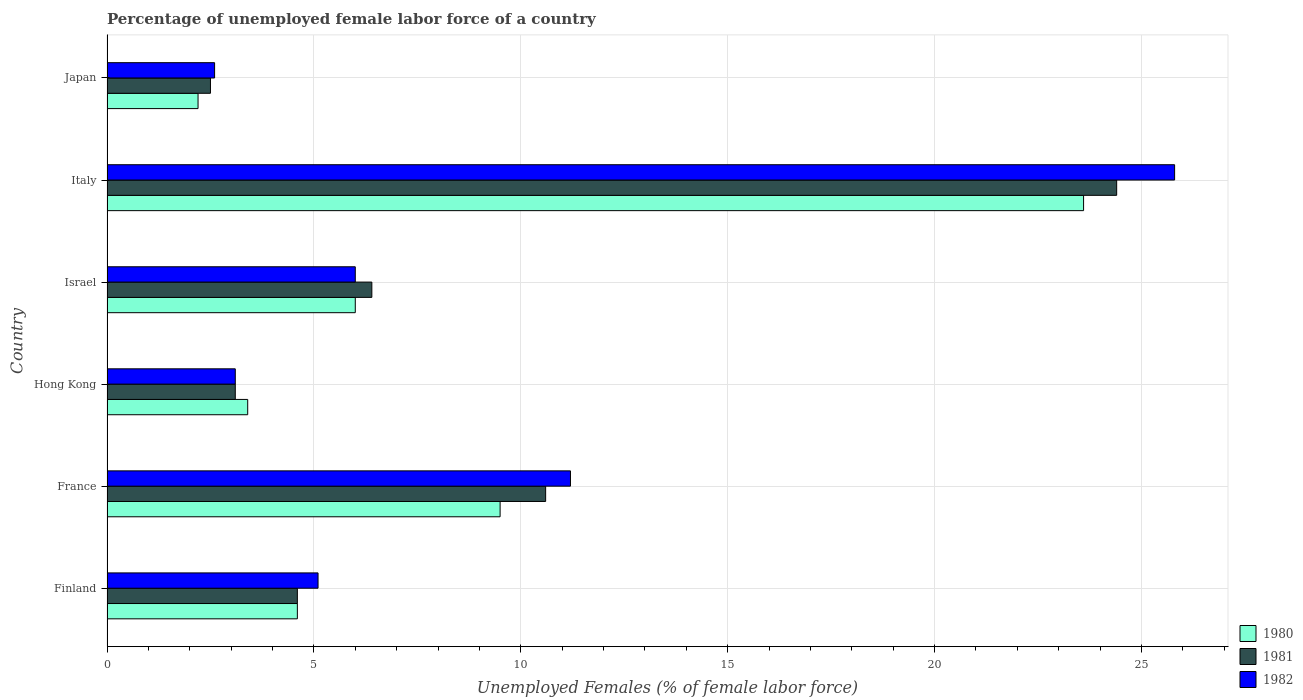Are the number of bars per tick equal to the number of legend labels?
Give a very brief answer. Yes. Are the number of bars on each tick of the Y-axis equal?
Your response must be concise. Yes. What is the label of the 3rd group of bars from the top?
Provide a short and direct response. Israel. What is the percentage of unemployed female labor force in 1982 in France?
Your answer should be very brief. 11.2. Across all countries, what is the maximum percentage of unemployed female labor force in 1980?
Ensure brevity in your answer.  23.6. Across all countries, what is the minimum percentage of unemployed female labor force in 1982?
Your response must be concise. 2.6. In which country was the percentage of unemployed female labor force in 1981 maximum?
Your response must be concise. Italy. What is the total percentage of unemployed female labor force in 1980 in the graph?
Offer a terse response. 49.3. What is the difference between the percentage of unemployed female labor force in 1980 in Finland and that in Japan?
Your answer should be compact. 2.4. What is the average percentage of unemployed female labor force in 1981 per country?
Your answer should be compact. 8.6. What is the difference between the percentage of unemployed female labor force in 1982 and percentage of unemployed female labor force in 1981 in Japan?
Your answer should be very brief. 0.1. What is the ratio of the percentage of unemployed female labor force in 1980 in France to that in Italy?
Offer a terse response. 0.4. What is the difference between the highest and the second highest percentage of unemployed female labor force in 1982?
Offer a terse response. 14.6. What is the difference between the highest and the lowest percentage of unemployed female labor force in 1982?
Give a very brief answer. 23.2. In how many countries, is the percentage of unemployed female labor force in 1981 greater than the average percentage of unemployed female labor force in 1981 taken over all countries?
Give a very brief answer. 2. Is the sum of the percentage of unemployed female labor force in 1981 in Israel and Japan greater than the maximum percentage of unemployed female labor force in 1980 across all countries?
Make the answer very short. No. What does the 1st bar from the top in France represents?
Provide a succinct answer. 1982. Is it the case that in every country, the sum of the percentage of unemployed female labor force in 1980 and percentage of unemployed female labor force in 1981 is greater than the percentage of unemployed female labor force in 1982?
Provide a short and direct response. Yes. How many bars are there?
Provide a short and direct response. 18. What is the difference between two consecutive major ticks on the X-axis?
Offer a terse response. 5. Does the graph contain grids?
Keep it short and to the point. Yes. What is the title of the graph?
Give a very brief answer. Percentage of unemployed female labor force of a country. What is the label or title of the X-axis?
Offer a very short reply. Unemployed Females (% of female labor force). What is the label or title of the Y-axis?
Give a very brief answer. Country. What is the Unemployed Females (% of female labor force) in 1980 in Finland?
Provide a succinct answer. 4.6. What is the Unemployed Females (% of female labor force) in 1981 in Finland?
Your response must be concise. 4.6. What is the Unemployed Females (% of female labor force) in 1982 in Finland?
Give a very brief answer. 5.1. What is the Unemployed Females (% of female labor force) of 1980 in France?
Provide a short and direct response. 9.5. What is the Unemployed Females (% of female labor force) of 1981 in France?
Keep it short and to the point. 10.6. What is the Unemployed Females (% of female labor force) of 1982 in France?
Make the answer very short. 11.2. What is the Unemployed Females (% of female labor force) in 1980 in Hong Kong?
Your answer should be compact. 3.4. What is the Unemployed Females (% of female labor force) in 1981 in Hong Kong?
Give a very brief answer. 3.1. What is the Unemployed Females (% of female labor force) in 1982 in Hong Kong?
Ensure brevity in your answer.  3.1. What is the Unemployed Females (% of female labor force) in 1980 in Israel?
Provide a short and direct response. 6. What is the Unemployed Females (% of female labor force) of 1981 in Israel?
Ensure brevity in your answer.  6.4. What is the Unemployed Females (% of female labor force) of 1980 in Italy?
Keep it short and to the point. 23.6. What is the Unemployed Females (% of female labor force) of 1981 in Italy?
Offer a very short reply. 24.4. What is the Unemployed Females (% of female labor force) in 1982 in Italy?
Offer a terse response. 25.8. What is the Unemployed Females (% of female labor force) in 1980 in Japan?
Offer a terse response. 2.2. What is the Unemployed Females (% of female labor force) of 1981 in Japan?
Give a very brief answer. 2.5. What is the Unemployed Females (% of female labor force) of 1982 in Japan?
Ensure brevity in your answer.  2.6. Across all countries, what is the maximum Unemployed Females (% of female labor force) of 1980?
Your answer should be compact. 23.6. Across all countries, what is the maximum Unemployed Females (% of female labor force) in 1981?
Make the answer very short. 24.4. Across all countries, what is the maximum Unemployed Females (% of female labor force) of 1982?
Provide a short and direct response. 25.8. Across all countries, what is the minimum Unemployed Females (% of female labor force) in 1980?
Ensure brevity in your answer.  2.2. Across all countries, what is the minimum Unemployed Females (% of female labor force) in 1982?
Your answer should be compact. 2.6. What is the total Unemployed Females (% of female labor force) of 1980 in the graph?
Provide a short and direct response. 49.3. What is the total Unemployed Females (% of female labor force) in 1981 in the graph?
Your answer should be compact. 51.6. What is the total Unemployed Females (% of female labor force) in 1982 in the graph?
Your answer should be compact. 53.8. What is the difference between the Unemployed Females (% of female labor force) in 1982 in Finland and that in France?
Offer a terse response. -6.1. What is the difference between the Unemployed Females (% of female labor force) of 1980 in Finland and that in Hong Kong?
Ensure brevity in your answer.  1.2. What is the difference between the Unemployed Females (% of female labor force) of 1980 in Finland and that in Israel?
Your answer should be compact. -1.4. What is the difference between the Unemployed Females (% of female labor force) in 1981 in Finland and that in Israel?
Your answer should be very brief. -1.8. What is the difference between the Unemployed Females (% of female labor force) in 1980 in Finland and that in Italy?
Your answer should be compact. -19. What is the difference between the Unemployed Females (% of female labor force) of 1981 in Finland and that in Italy?
Your answer should be very brief. -19.8. What is the difference between the Unemployed Females (% of female labor force) of 1982 in Finland and that in Italy?
Ensure brevity in your answer.  -20.7. What is the difference between the Unemployed Females (% of female labor force) of 1980 in Finland and that in Japan?
Provide a short and direct response. 2.4. What is the difference between the Unemployed Females (% of female labor force) of 1981 in Finland and that in Japan?
Provide a short and direct response. 2.1. What is the difference between the Unemployed Females (% of female labor force) in 1982 in Finland and that in Japan?
Give a very brief answer. 2.5. What is the difference between the Unemployed Females (% of female labor force) in 1980 in France and that in Hong Kong?
Offer a terse response. 6.1. What is the difference between the Unemployed Females (% of female labor force) of 1981 in France and that in Hong Kong?
Offer a terse response. 7.5. What is the difference between the Unemployed Females (% of female labor force) in 1980 in France and that in Israel?
Your response must be concise. 3.5. What is the difference between the Unemployed Females (% of female labor force) of 1980 in France and that in Italy?
Give a very brief answer. -14.1. What is the difference between the Unemployed Females (% of female labor force) in 1982 in France and that in Italy?
Your answer should be very brief. -14.6. What is the difference between the Unemployed Females (% of female labor force) in 1982 in France and that in Japan?
Your response must be concise. 8.6. What is the difference between the Unemployed Females (% of female labor force) in 1980 in Hong Kong and that in Israel?
Provide a succinct answer. -2.6. What is the difference between the Unemployed Females (% of female labor force) of 1981 in Hong Kong and that in Israel?
Offer a very short reply. -3.3. What is the difference between the Unemployed Females (% of female labor force) of 1980 in Hong Kong and that in Italy?
Provide a succinct answer. -20.2. What is the difference between the Unemployed Females (% of female labor force) in 1981 in Hong Kong and that in Italy?
Offer a very short reply. -21.3. What is the difference between the Unemployed Females (% of female labor force) in 1982 in Hong Kong and that in Italy?
Your answer should be compact. -22.7. What is the difference between the Unemployed Females (% of female labor force) in 1980 in Hong Kong and that in Japan?
Your answer should be compact. 1.2. What is the difference between the Unemployed Females (% of female labor force) of 1981 in Hong Kong and that in Japan?
Your answer should be compact. 0.6. What is the difference between the Unemployed Females (% of female labor force) of 1982 in Hong Kong and that in Japan?
Your answer should be very brief. 0.5. What is the difference between the Unemployed Females (% of female labor force) in 1980 in Israel and that in Italy?
Provide a short and direct response. -17.6. What is the difference between the Unemployed Females (% of female labor force) of 1981 in Israel and that in Italy?
Your response must be concise. -18. What is the difference between the Unemployed Females (% of female labor force) in 1982 in Israel and that in Italy?
Make the answer very short. -19.8. What is the difference between the Unemployed Females (% of female labor force) in 1980 in Israel and that in Japan?
Your answer should be very brief. 3.8. What is the difference between the Unemployed Females (% of female labor force) of 1981 in Israel and that in Japan?
Offer a very short reply. 3.9. What is the difference between the Unemployed Females (% of female labor force) in 1982 in Israel and that in Japan?
Provide a succinct answer. 3.4. What is the difference between the Unemployed Females (% of female labor force) of 1980 in Italy and that in Japan?
Give a very brief answer. 21.4. What is the difference between the Unemployed Females (% of female labor force) in 1981 in Italy and that in Japan?
Keep it short and to the point. 21.9. What is the difference between the Unemployed Females (% of female labor force) in 1982 in Italy and that in Japan?
Give a very brief answer. 23.2. What is the difference between the Unemployed Females (% of female labor force) of 1980 in Finland and the Unemployed Females (% of female labor force) of 1981 in France?
Provide a succinct answer. -6. What is the difference between the Unemployed Females (% of female labor force) in 1981 in Finland and the Unemployed Females (% of female labor force) in 1982 in Hong Kong?
Give a very brief answer. 1.5. What is the difference between the Unemployed Females (% of female labor force) in 1980 in Finland and the Unemployed Females (% of female labor force) in 1982 in Israel?
Give a very brief answer. -1.4. What is the difference between the Unemployed Females (% of female labor force) of 1980 in Finland and the Unemployed Females (% of female labor force) of 1981 in Italy?
Make the answer very short. -19.8. What is the difference between the Unemployed Females (% of female labor force) of 1980 in Finland and the Unemployed Females (% of female labor force) of 1982 in Italy?
Provide a succinct answer. -21.2. What is the difference between the Unemployed Females (% of female labor force) in 1981 in Finland and the Unemployed Females (% of female labor force) in 1982 in Italy?
Provide a short and direct response. -21.2. What is the difference between the Unemployed Females (% of female labor force) in 1980 in France and the Unemployed Females (% of female labor force) in 1982 in Hong Kong?
Keep it short and to the point. 6.4. What is the difference between the Unemployed Females (% of female labor force) in 1981 in France and the Unemployed Females (% of female labor force) in 1982 in Hong Kong?
Ensure brevity in your answer.  7.5. What is the difference between the Unemployed Females (% of female labor force) of 1980 in France and the Unemployed Females (% of female labor force) of 1981 in Israel?
Make the answer very short. 3.1. What is the difference between the Unemployed Females (% of female labor force) of 1981 in France and the Unemployed Females (% of female labor force) of 1982 in Israel?
Keep it short and to the point. 4.6. What is the difference between the Unemployed Females (% of female labor force) of 1980 in France and the Unemployed Females (% of female labor force) of 1981 in Italy?
Your response must be concise. -14.9. What is the difference between the Unemployed Females (% of female labor force) in 1980 in France and the Unemployed Females (% of female labor force) in 1982 in Italy?
Give a very brief answer. -16.3. What is the difference between the Unemployed Females (% of female labor force) of 1981 in France and the Unemployed Females (% of female labor force) of 1982 in Italy?
Your answer should be compact. -15.2. What is the difference between the Unemployed Females (% of female labor force) in 1980 in France and the Unemployed Females (% of female labor force) in 1982 in Japan?
Make the answer very short. 6.9. What is the difference between the Unemployed Females (% of female labor force) of 1980 in Hong Kong and the Unemployed Females (% of female labor force) of 1982 in Israel?
Offer a very short reply. -2.6. What is the difference between the Unemployed Females (% of female labor force) in 1980 in Hong Kong and the Unemployed Females (% of female labor force) in 1981 in Italy?
Your response must be concise. -21. What is the difference between the Unemployed Females (% of female labor force) of 1980 in Hong Kong and the Unemployed Females (% of female labor force) of 1982 in Italy?
Provide a short and direct response. -22.4. What is the difference between the Unemployed Females (% of female labor force) in 1981 in Hong Kong and the Unemployed Females (% of female labor force) in 1982 in Italy?
Provide a short and direct response. -22.7. What is the difference between the Unemployed Females (% of female labor force) of 1980 in Hong Kong and the Unemployed Females (% of female labor force) of 1981 in Japan?
Make the answer very short. 0.9. What is the difference between the Unemployed Females (% of female labor force) in 1980 in Israel and the Unemployed Females (% of female labor force) in 1981 in Italy?
Provide a short and direct response. -18.4. What is the difference between the Unemployed Females (% of female labor force) of 1980 in Israel and the Unemployed Females (% of female labor force) of 1982 in Italy?
Offer a very short reply. -19.8. What is the difference between the Unemployed Females (% of female labor force) in 1981 in Israel and the Unemployed Females (% of female labor force) in 1982 in Italy?
Provide a short and direct response. -19.4. What is the difference between the Unemployed Females (% of female labor force) in 1980 in Italy and the Unemployed Females (% of female labor force) in 1981 in Japan?
Give a very brief answer. 21.1. What is the difference between the Unemployed Females (% of female labor force) of 1981 in Italy and the Unemployed Females (% of female labor force) of 1982 in Japan?
Your answer should be very brief. 21.8. What is the average Unemployed Females (% of female labor force) in 1980 per country?
Your answer should be very brief. 8.22. What is the average Unemployed Females (% of female labor force) in 1981 per country?
Your answer should be compact. 8.6. What is the average Unemployed Females (% of female labor force) in 1982 per country?
Your answer should be very brief. 8.97. What is the difference between the Unemployed Females (% of female labor force) of 1980 and Unemployed Females (% of female labor force) of 1981 in France?
Your answer should be compact. -1.1. What is the difference between the Unemployed Females (% of female labor force) of 1980 and Unemployed Females (% of female labor force) of 1982 in France?
Your answer should be very brief. -1.7. What is the difference between the Unemployed Females (% of female labor force) in 1980 and Unemployed Females (% of female labor force) in 1981 in Hong Kong?
Provide a succinct answer. 0.3. What is the difference between the Unemployed Females (% of female labor force) of 1980 and Unemployed Females (% of female labor force) of 1982 in Israel?
Your answer should be very brief. 0. What is the difference between the Unemployed Females (% of female labor force) of 1981 and Unemployed Females (% of female labor force) of 1982 in Israel?
Give a very brief answer. 0.4. What is the difference between the Unemployed Females (% of female labor force) of 1981 and Unemployed Females (% of female labor force) of 1982 in Italy?
Your answer should be very brief. -1.4. What is the difference between the Unemployed Females (% of female labor force) in 1980 and Unemployed Females (% of female labor force) in 1982 in Japan?
Offer a terse response. -0.4. What is the ratio of the Unemployed Females (% of female labor force) in 1980 in Finland to that in France?
Offer a very short reply. 0.48. What is the ratio of the Unemployed Females (% of female labor force) in 1981 in Finland to that in France?
Your answer should be compact. 0.43. What is the ratio of the Unemployed Females (% of female labor force) in 1982 in Finland to that in France?
Your answer should be very brief. 0.46. What is the ratio of the Unemployed Females (% of female labor force) in 1980 in Finland to that in Hong Kong?
Make the answer very short. 1.35. What is the ratio of the Unemployed Females (% of female labor force) of 1981 in Finland to that in Hong Kong?
Provide a succinct answer. 1.48. What is the ratio of the Unemployed Females (% of female labor force) of 1982 in Finland to that in Hong Kong?
Give a very brief answer. 1.65. What is the ratio of the Unemployed Females (% of female labor force) in 1980 in Finland to that in Israel?
Provide a succinct answer. 0.77. What is the ratio of the Unemployed Females (% of female labor force) in 1981 in Finland to that in Israel?
Ensure brevity in your answer.  0.72. What is the ratio of the Unemployed Females (% of female labor force) of 1980 in Finland to that in Italy?
Provide a short and direct response. 0.19. What is the ratio of the Unemployed Females (% of female labor force) of 1981 in Finland to that in Italy?
Your answer should be compact. 0.19. What is the ratio of the Unemployed Females (% of female labor force) of 1982 in Finland to that in Italy?
Your response must be concise. 0.2. What is the ratio of the Unemployed Females (% of female labor force) in 1980 in Finland to that in Japan?
Ensure brevity in your answer.  2.09. What is the ratio of the Unemployed Females (% of female labor force) in 1981 in Finland to that in Japan?
Your response must be concise. 1.84. What is the ratio of the Unemployed Females (% of female labor force) of 1982 in Finland to that in Japan?
Your answer should be compact. 1.96. What is the ratio of the Unemployed Females (% of female labor force) in 1980 in France to that in Hong Kong?
Offer a terse response. 2.79. What is the ratio of the Unemployed Females (% of female labor force) of 1981 in France to that in Hong Kong?
Offer a terse response. 3.42. What is the ratio of the Unemployed Females (% of female labor force) in 1982 in France to that in Hong Kong?
Make the answer very short. 3.61. What is the ratio of the Unemployed Females (% of female labor force) of 1980 in France to that in Israel?
Keep it short and to the point. 1.58. What is the ratio of the Unemployed Females (% of female labor force) in 1981 in France to that in Israel?
Give a very brief answer. 1.66. What is the ratio of the Unemployed Females (% of female labor force) of 1982 in France to that in Israel?
Your answer should be very brief. 1.87. What is the ratio of the Unemployed Females (% of female labor force) in 1980 in France to that in Italy?
Keep it short and to the point. 0.4. What is the ratio of the Unemployed Females (% of female labor force) in 1981 in France to that in Italy?
Your response must be concise. 0.43. What is the ratio of the Unemployed Females (% of female labor force) of 1982 in France to that in Italy?
Your answer should be very brief. 0.43. What is the ratio of the Unemployed Females (% of female labor force) in 1980 in France to that in Japan?
Make the answer very short. 4.32. What is the ratio of the Unemployed Females (% of female labor force) of 1981 in France to that in Japan?
Keep it short and to the point. 4.24. What is the ratio of the Unemployed Females (% of female labor force) of 1982 in France to that in Japan?
Your answer should be compact. 4.31. What is the ratio of the Unemployed Females (% of female labor force) in 1980 in Hong Kong to that in Israel?
Offer a terse response. 0.57. What is the ratio of the Unemployed Females (% of female labor force) of 1981 in Hong Kong to that in Israel?
Give a very brief answer. 0.48. What is the ratio of the Unemployed Females (% of female labor force) of 1982 in Hong Kong to that in Israel?
Provide a succinct answer. 0.52. What is the ratio of the Unemployed Females (% of female labor force) of 1980 in Hong Kong to that in Italy?
Give a very brief answer. 0.14. What is the ratio of the Unemployed Females (% of female labor force) in 1981 in Hong Kong to that in Italy?
Keep it short and to the point. 0.13. What is the ratio of the Unemployed Females (% of female labor force) in 1982 in Hong Kong to that in Italy?
Your answer should be very brief. 0.12. What is the ratio of the Unemployed Females (% of female labor force) in 1980 in Hong Kong to that in Japan?
Ensure brevity in your answer.  1.55. What is the ratio of the Unemployed Females (% of female labor force) of 1981 in Hong Kong to that in Japan?
Provide a succinct answer. 1.24. What is the ratio of the Unemployed Females (% of female labor force) of 1982 in Hong Kong to that in Japan?
Offer a very short reply. 1.19. What is the ratio of the Unemployed Females (% of female labor force) in 1980 in Israel to that in Italy?
Offer a very short reply. 0.25. What is the ratio of the Unemployed Females (% of female labor force) of 1981 in Israel to that in Italy?
Ensure brevity in your answer.  0.26. What is the ratio of the Unemployed Females (% of female labor force) in 1982 in Israel to that in Italy?
Give a very brief answer. 0.23. What is the ratio of the Unemployed Females (% of female labor force) of 1980 in Israel to that in Japan?
Provide a succinct answer. 2.73. What is the ratio of the Unemployed Females (% of female labor force) in 1981 in Israel to that in Japan?
Offer a terse response. 2.56. What is the ratio of the Unemployed Females (% of female labor force) of 1982 in Israel to that in Japan?
Provide a succinct answer. 2.31. What is the ratio of the Unemployed Females (% of female labor force) of 1980 in Italy to that in Japan?
Provide a succinct answer. 10.73. What is the ratio of the Unemployed Females (% of female labor force) of 1981 in Italy to that in Japan?
Provide a short and direct response. 9.76. What is the ratio of the Unemployed Females (% of female labor force) in 1982 in Italy to that in Japan?
Offer a terse response. 9.92. What is the difference between the highest and the second highest Unemployed Females (% of female labor force) of 1980?
Keep it short and to the point. 14.1. What is the difference between the highest and the second highest Unemployed Females (% of female labor force) of 1982?
Give a very brief answer. 14.6. What is the difference between the highest and the lowest Unemployed Females (% of female labor force) of 1980?
Give a very brief answer. 21.4. What is the difference between the highest and the lowest Unemployed Females (% of female labor force) of 1981?
Make the answer very short. 21.9. What is the difference between the highest and the lowest Unemployed Females (% of female labor force) of 1982?
Your answer should be very brief. 23.2. 